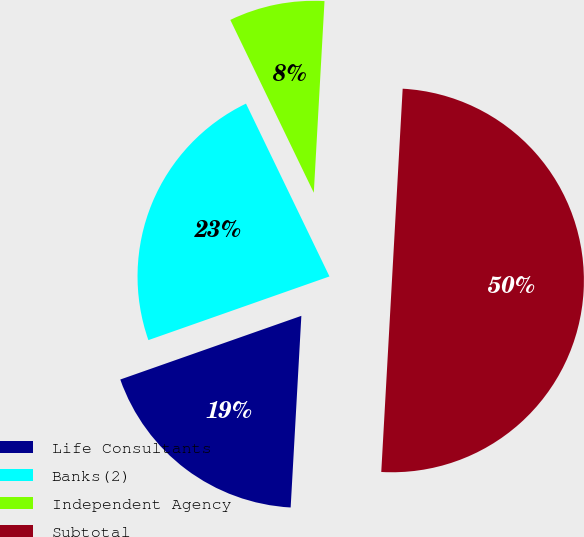Convert chart. <chart><loc_0><loc_0><loc_500><loc_500><pie_chart><fcel>Life Consultants<fcel>Banks(2)<fcel>Independent Agency<fcel>Subtotal<nl><fcel>18.73%<fcel>23.22%<fcel>8.05%<fcel>50.0%<nl></chart> 